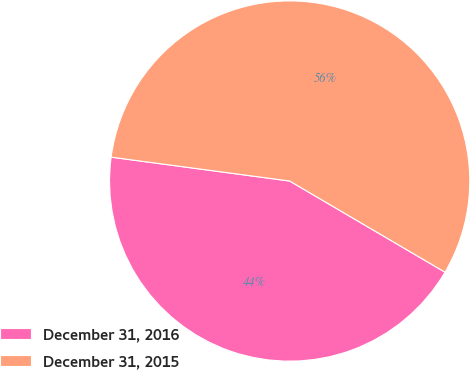<chart> <loc_0><loc_0><loc_500><loc_500><pie_chart><fcel>December 31, 2016<fcel>December 31, 2015<nl><fcel>43.67%<fcel>56.33%<nl></chart> 